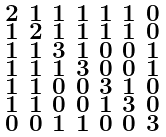<formula> <loc_0><loc_0><loc_500><loc_500>\begin{smallmatrix} 2 & 1 & 1 & 1 & 1 & 1 & 0 \\ 1 & 2 & 1 & 1 & 1 & 1 & 0 \\ 1 & 1 & 3 & 1 & 0 & 0 & 1 \\ 1 & 1 & 1 & 3 & 0 & 0 & 1 \\ 1 & 1 & 0 & 0 & 3 & 1 & 0 \\ 1 & 1 & 0 & 0 & 1 & 3 & 0 \\ 0 & 0 & 1 & 1 & 0 & 0 & 3 \end{smallmatrix}</formula> 